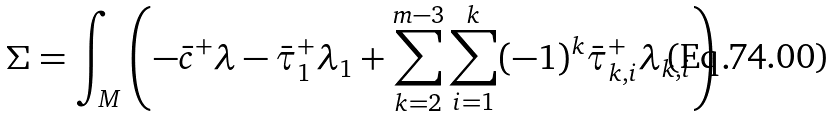Convert formula to latex. <formula><loc_0><loc_0><loc_500><loc_500>\Sigma = \int _ { M } \left ( - \bar { c } ^ { + } \lambda - \bar { \tau } _ { 1 } ^ { + } \lambda _ { 1 } + \sum _ { k = 2 } ^ { m - 3 } \sum _ { i = 1 } ^ { k } ( - 1 ) ^ { k } \bar { \tau } _ { k , i } ^ { + } \lambda _ { k , i } \right ) .</formula> 